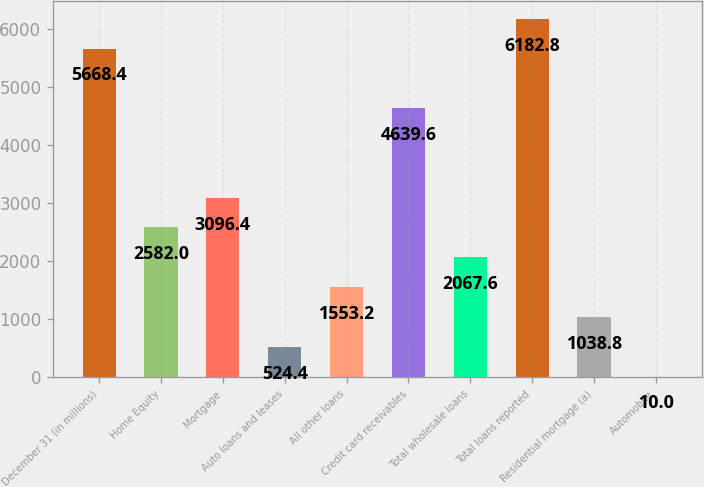<chart> <loc_0><loc_0><loc_500><loc_500><bar_chart><fcel>December 31 (in millions)<fcel>Home Equity<fcel>Mortgage<fcel>Auto loans and leases<fcel>All other loans<fcel>Credit card receivables<fcel>Total wholesale loans<fcel>Total loans reported<fcel>Residential mortgage (a)<fcel>Automobile<nl><fcel>5668.4<fcel>2582<fcel>3096.4<fcel>524.4<fcel>1553.2<fcel>4639.6<fcel>2067.6<fcel>6182.8<fcel>1038.8<fcel>10<nl></chart> 